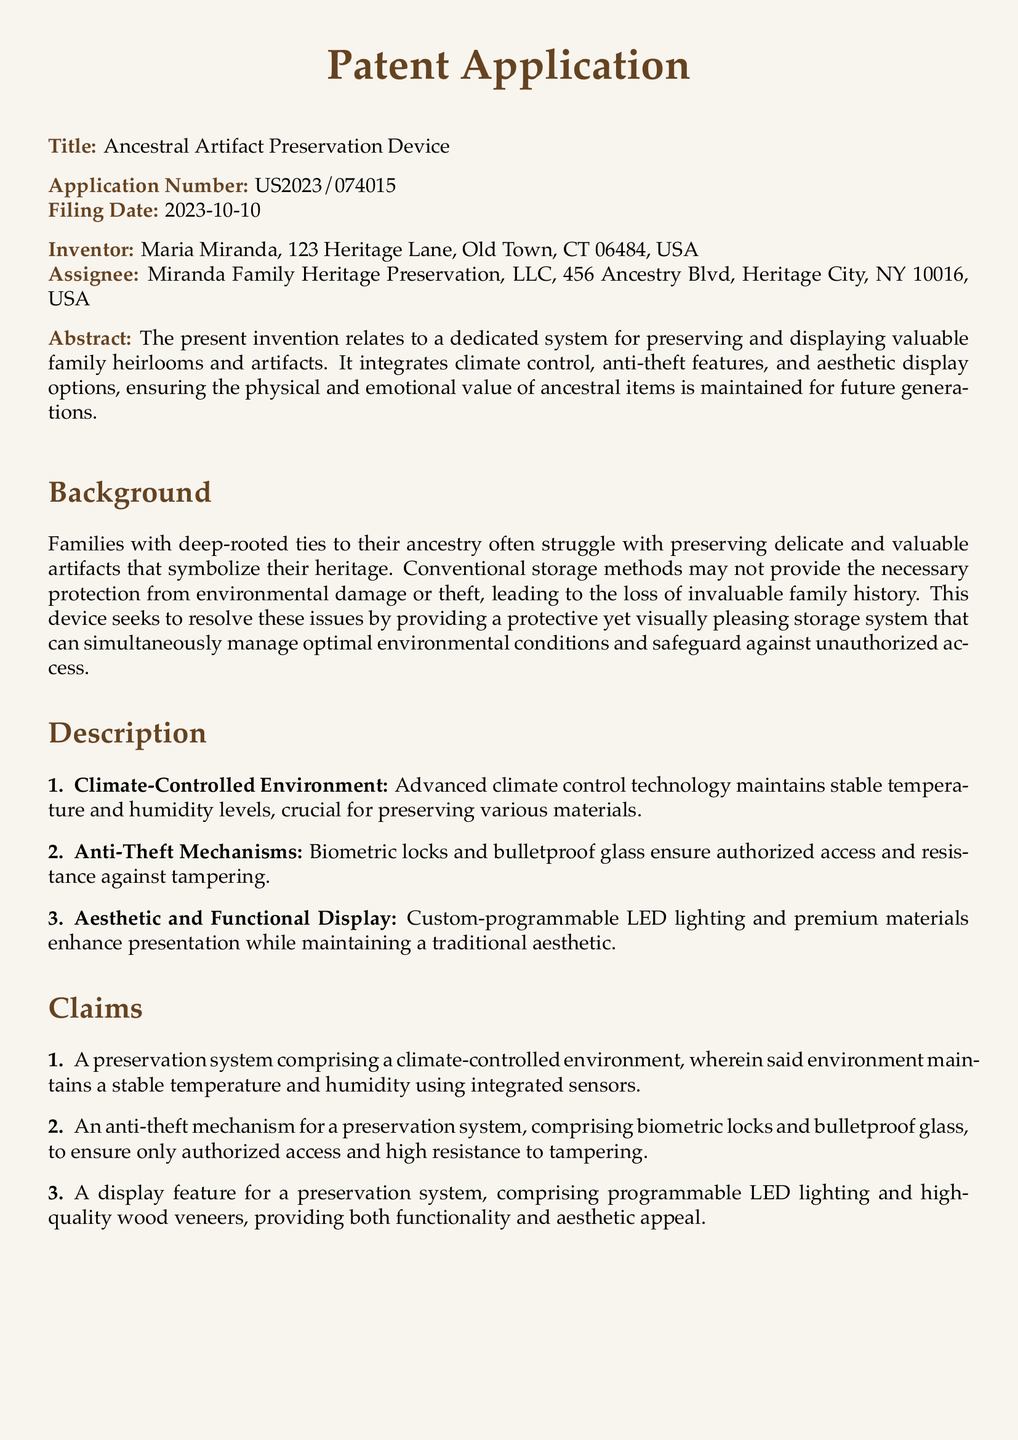What is the title of the invention? The title of the invention is found at the top of the document under the field "Title."
Answer: Ancestral Artifact Preservation Device Who is the inventor? The inventor's name is listed in the field "Inventor."
Answer: Maria Miranda What is the application number? The application number can be found under the field "Application Number."
Answer: US2023/074015 What date was the application filed? The filing date is specified under the field "Filing Date."
Answer: 2023-10-10 What is the purpose of the device? The purpose is described in the abstract, focusing on preserving and displaying items.
Answer: Preserving and displaying valuable family heirlooms and artifacts Which feature ensures authorized access? The anti-theft features mentioned in the description include specific mechanisms for security.
Answer: Biometric locks How many claims are listed in the document? The number of claims can be counted in the "Claims" section.
Answer: Three What technology is used for climate control? The description specifies the mechanism used for maintaining environmental conditions.
Answer: Advanced climate control technology What materials enhance the aesthetic display? The display feature mentions specific materials that contribute to visual appeal.
Answer: Premium materials 